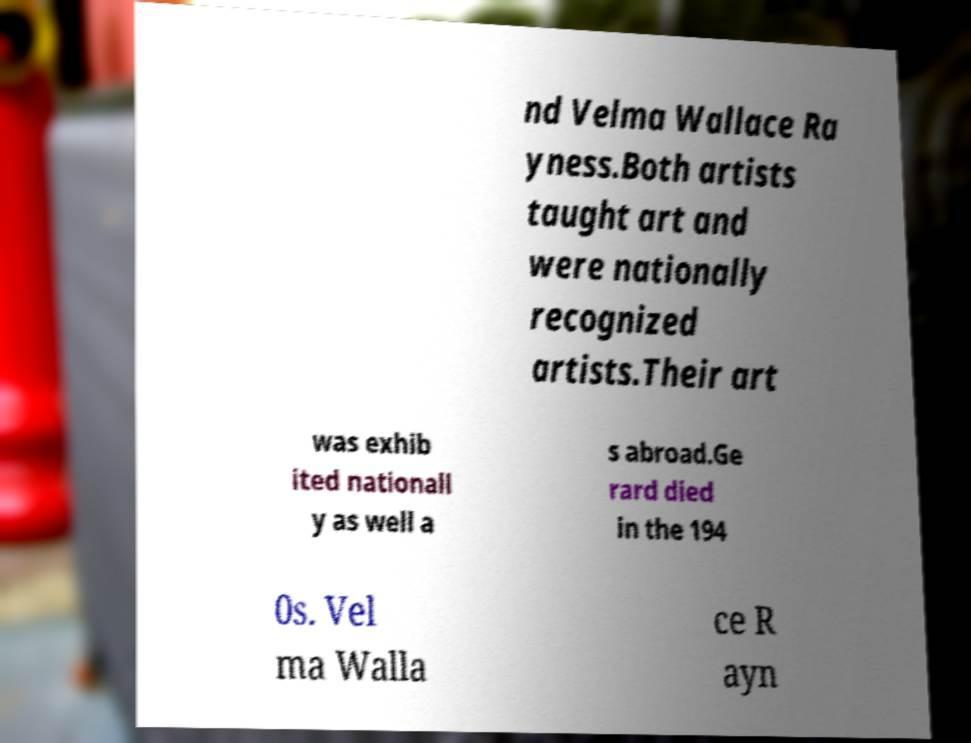Could you extract and type out the text from this image? nd Velma Wallace Ra yness.Both artists taught art and were nationally recognized artists.Their art was exhib ited nationall y as well a s abroad.Ge rard died in the 194 0s. Vel ma Walla ce R ayn 